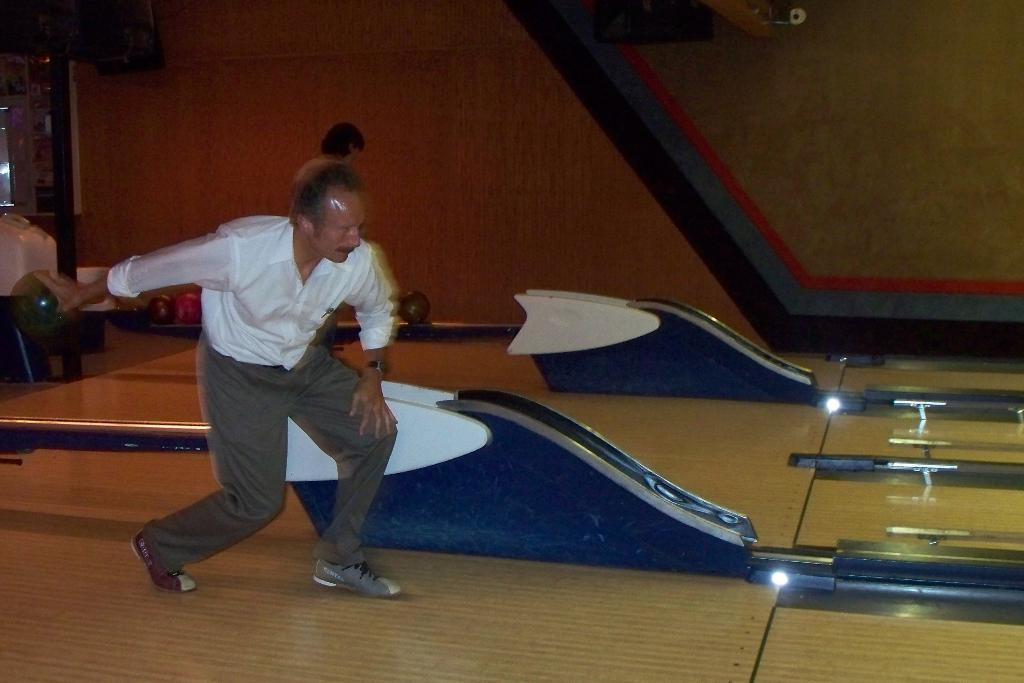What is the man in the image holding? The man is holding a ball in the image. How many balls can be seen in the image? There are balls visible in the image. What type of flooring is present in the image? The floor in the image appears to be made of wood. What arithmetic problem is the man solving in the image? There is no arithmetic problem present in the image; the man is holding a ball. What type of pets are visible in the image? There are no pets visible in the image. 